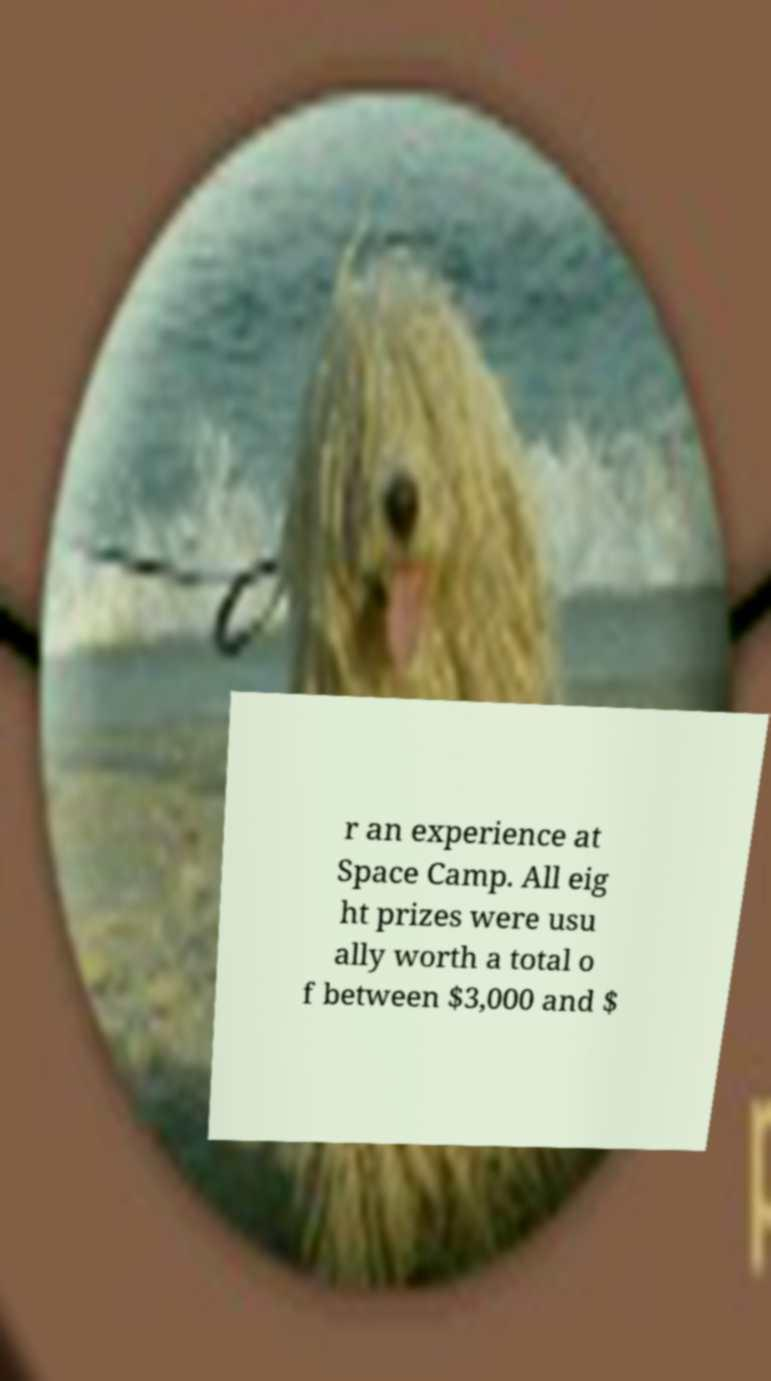I need the written content from this picture converted into text. Can you do that? r an experience at Space Camp. All eig ht prizes were usu ally worth a total o f between $3,000 and $ 